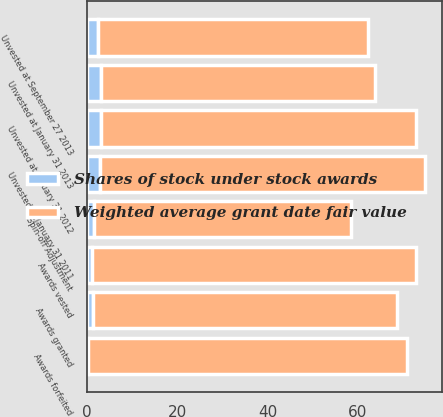Convert chart. <chart><loc_0><loc_0><loc_500><loc_500><stacked_bar_chart><ecel><fcel>Unvested at January 31 2011<fcel>Awards granted<fcel>Awards forfeited<fcel>Awards vested<fcel>Unvested at January 31 2012<fcel>Unvested at January 31 2013<fcel>Spin-off Adjustment<fcel>Unvested at September 27 2013<nl><fcel>Shares of stock under stock awards<fcel>2.9<fcel>1.4<fcel>0.3<fcel>1<fcel>3<fcel>3.1<fcel>1.5<fcel>2.4<nl><fcel>Weighted average grant date fair value<fcel>72.12<fcel>67.32<fcel>70.72<fcel>72<fcel>70<fcel>60.78<fcel>57.04<fcel>59.98<nl></chart> 